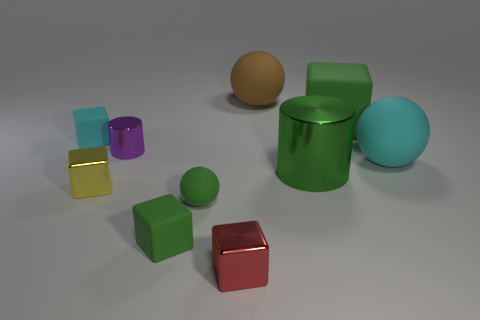Considering the arrangement of the objects, what can you infer about the intent of the composition? The arrangement of the objects seems intentional and carefully balanced to create a sense of harmony and contrast. The objects are spaced in such a way that they lead the eye through the composition, with the spheres providing curvilinear forms that contrast with the angularity of the cubes. This juxtaposition may suggest themes of diversity and unity, as different shapes coexist in a single space, or it could be an exploration of spatial relationships and volume in a three-dimensional environment. 